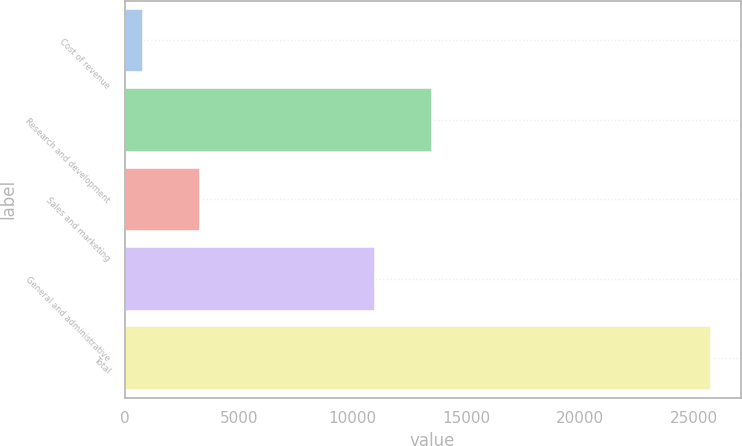Convert chart. <chart><loc_0><loc_0><loc_500><loc_500><bar_chart><fcel>Cost of revenue<fcel>Research and development<fcel>Sales and marketing<fcel>General and administrative<fcel>Total<nl><fcel>800<fcel>13467.1<fcel>3294.1<fcel>10973<fcel>25741<nl></chart> 